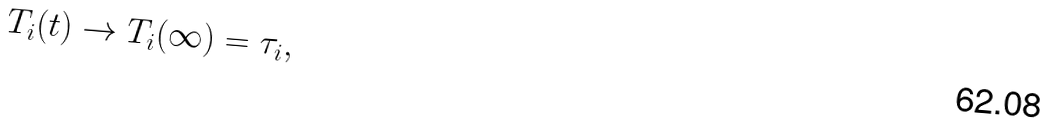<formula> <loc_0><loc_0><loc_500><loc_500>T _ { i } ( t ) \rightarrow T _ { i } ( \infty ) = \tau _ { i } ,</formula> 